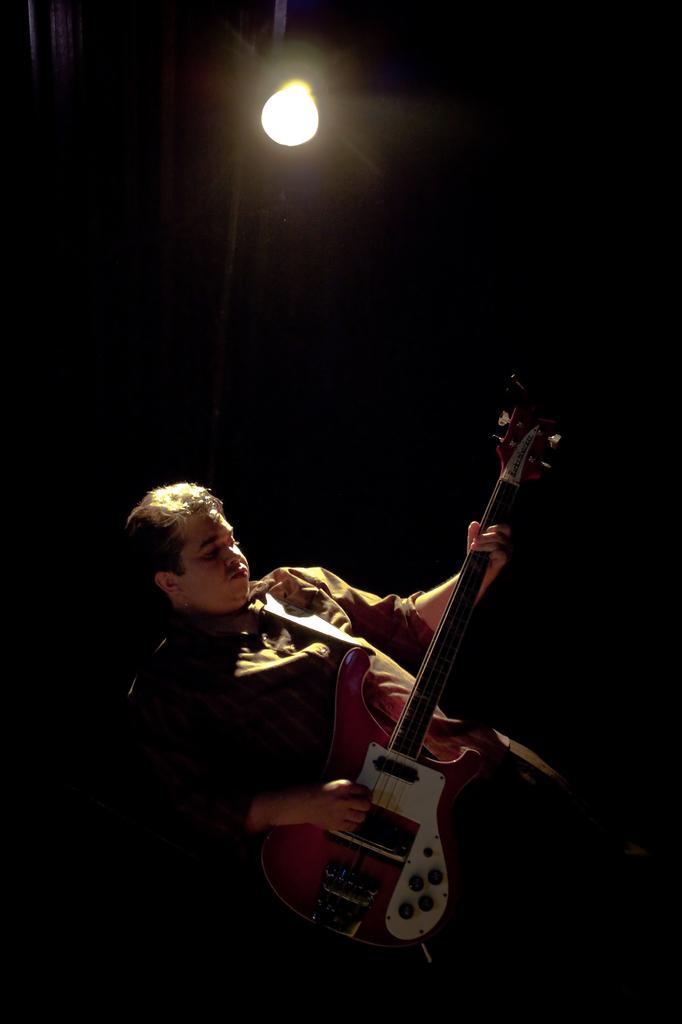How would you summarize this image in a sentence or two? In this picture there is a man playing guitar. On top of it there is a light. 